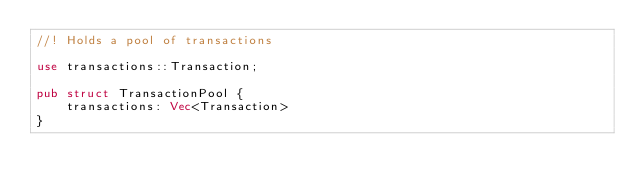<code> <loc_0><loc_0><loc_500><loc_500><_Rust_>//! Holds a pool of transactions

use transactions::Transaction;

pub struct TransactionPool {
    transactions: Vec<Transaction>
}</code> 